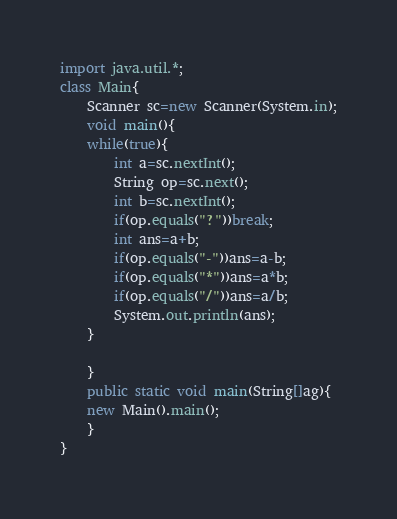Convert code to text. <code><loc_0><loc_0><loc_500><loc_500><_Java_>import java.util.*;
class Main{
    Scanner sc=new Scanner(System.in);
    void main(){
	while(true){
	    int a=sc.nextInt();
	    String op=sc.next();
	    int b=sc.nextInt();
	    if(op.equals("?"))break;
	    int ans=a+b;
	    if(op.equals("-"))ans=a-b;
	    if(op.equals("*"))ans=a*b;
	    if(op.equals("/"))ans=a/b;
	    System.out.println(ans);
	}
	
    }
    public static void main(String[]ag){
	new Main().main();
    }
}</code> 